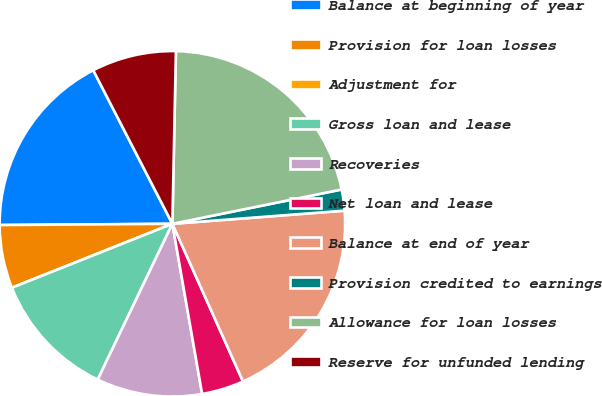<chart> <loc_0><loc_0><loc_500><loc_500><pie_chart><fcel>Balance at beginning of year<fcel>Provision for loan losses<fcel>Adjustment for<fcel>Gross loan and lease<fcel>Recoveries<fcel>Net loan and lease<fcel>Balance at end of year<fcel>Provision credited to earnings<fcel>Allowance for loan losses<fcel>Reserve for unfunded lending<nl><fcel>17.54%<fcel>5.92%<fcel>0.0%<fcel>11.85%<fcel>9.87%<fcel>3.95%<fcel>19.51%<fcel>1.97%<fcel>21.49%<fcel>7.9%<nl></chart> 